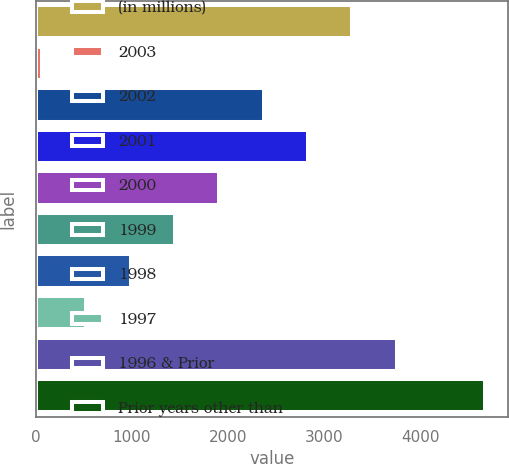<chart> <loc_0><loc_0><loc_500><loc_500><bar_chart><fcel>(in millions)<fcel>2003<fcel>2002<fcel>2001<fcel>2000<fcel>1999<fcel>1998<fcel>1997<fcel>1996 & Prior<fcel>Prior years other than<nl><fcel>3294.9<fcel>63<fcel>2371.5<fcel>2833.2<fcel>1909.8<fcel>1448.1<fcel>986.4<fcel>524.7<fcel>3756.6<fcel>4680<nl></chart> 